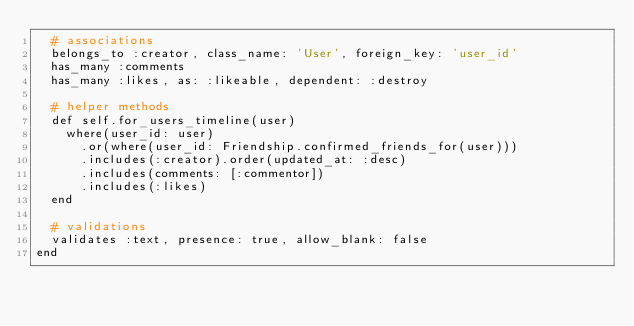<code> <loc_0><loc_0><loc_500><loc_500><_Ruby_>  # associations
  belongs_to :creator, class_name: 'User', foreign_key: 'user_id'
  has_many :comments
  has_many :likes, as: :likeable, dependent: :destroy

  # helper methods
  def self.for_users_timeline(user)
    where(user_id: user)
      .or(where(user_id: Friendship.confirmed_friends_for(user)))
      .includes(:creator).order(updated_at: :desc)
      .includes(comments: [:commentor])
      .includes(:likes)
  end

  # validations
  validates :text, presence: true, allow_blank: false
end
</code> 